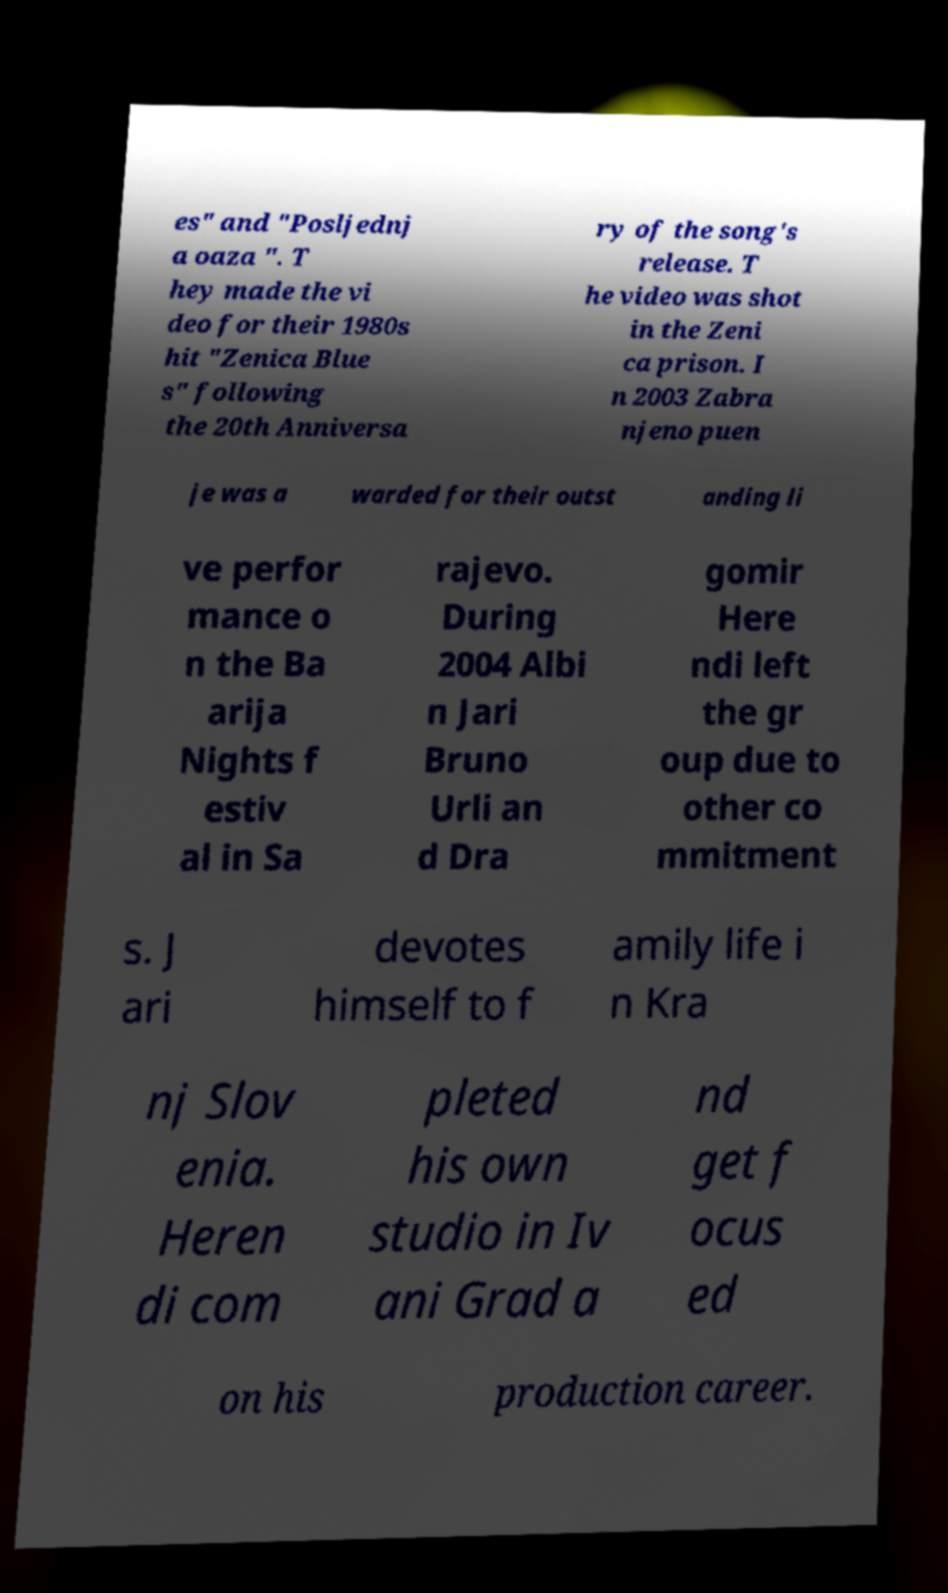Please identify and transcribe the text found in this image. es" and "Posljednj a oaza ". T hey made the vi deo for their 1980s hit "Zenica Blue s" following the 20th Anniversa ry of the song's release. T he video was shot in the Zeni ca prison. I n 2003 Zabra njeno puen je was a warded for their outst anding li ve perfor mance o n the Ba arija Nights f estiv al in Sa rajevo. During 2004 Albi n Jari Bruno Urli an d Dra gomir Here ndi left the gr oup due to other co mmitment s. J ari devotes himself to f amily life i n Kra nj Slov enia. Heren di com pleted his own studio in Iv ani Grad a nd get f ocus ed on his production career. 